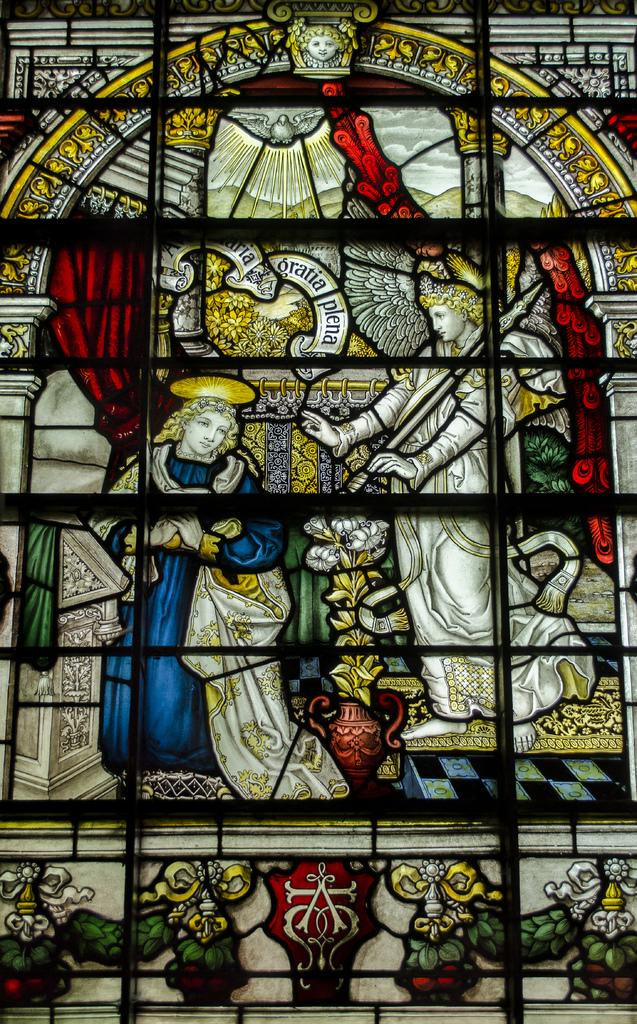What is the main subject of the image? There is a depiction of persons in the center of the image. What type of produce is being harvested by the persons in the image? There is no produce present in the image; it only depicts persons. What role does the stem play in the image? There is no stem present in the image. 